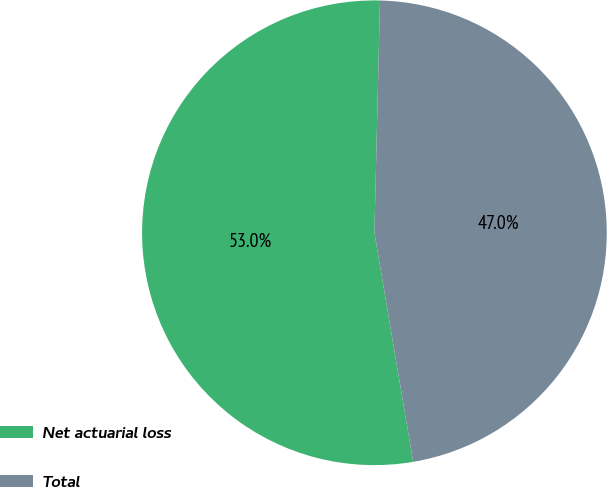Convert chart to OTSL. <chart><loc_0><loc_0><loc_500><loc_500><pie_chart><fcel>Net actuarial loss<fcel>Total<nl><fcel>53.05%<fcel>46.95%<nl></chart> 